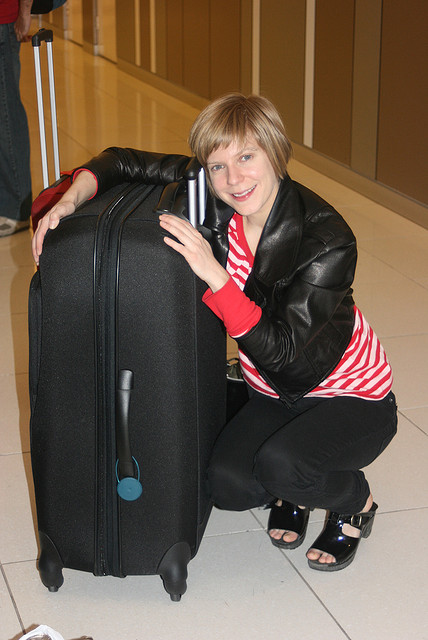<image>What is the brand name of the suitcase the lady is touching? It is not sure what the brand name of the suitcase the lady is touching. It might possibly be 'samsonite'. What is the brand name of the suitcase the lady is touching? I don't know what is the brand name of the suitcase the lady is touching. It can be 'samsonite' or any other brand. 